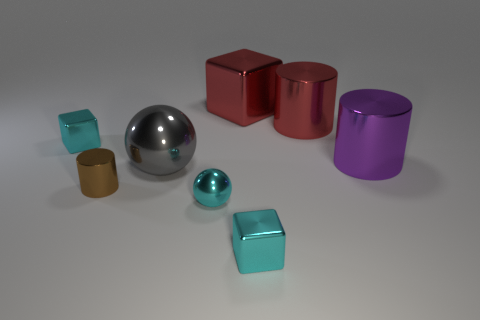Add 1 gray spheres. How many objects exist? 9 Subtract all spheres. How many objects are left? 6 Subtract all cyan metal blocks. Subtract all red objects. How many objects are left? 4 Add 6 spheres. How many spheres are left? 8 Add 2 tiny shiny objects. How many tiny shiny objects exist? 6 Subtract 1 red cylinders. How many objects are left? 7 